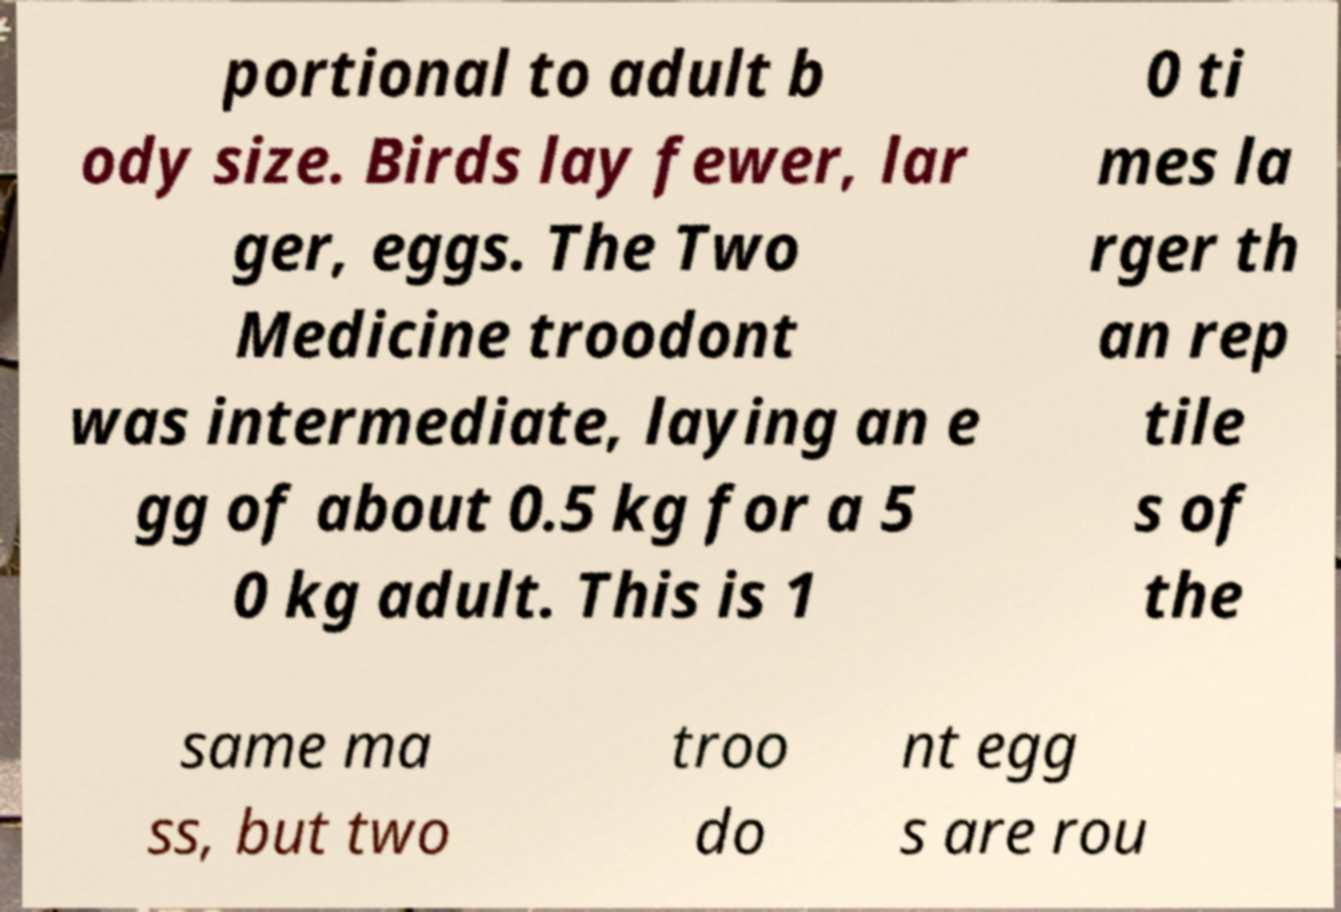Please read and relay the text visible in this image. What does it say? portional to adult b ody size. Birds lay fewer, lar ger, eggs. The Two Medicine troodont was intermediate, laying an e gg of about 0.5 kg for a 5 0 kg adult. This is 1 0 ti mes la rger th an rep tile s of the same ma ss, but two troo do nt egg s are rou 